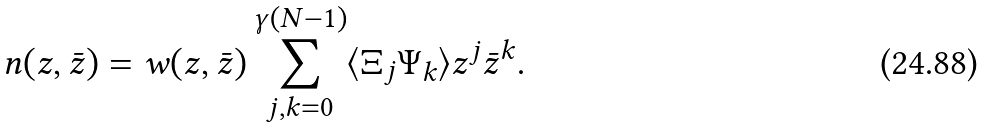Convert formula to latex. <formula><loc_0><loc_0><loc_500><loc_500>n ( z , \bar { z } ) = w ( z , \bar { z } ) \sum _ { j , k = 0 } ^ { \gamma ( N - 1 ) } \langle \Xi _ { j } \Psi _ { k } \rangle z ^ { j } \bar { z } ^ { k } .</formula> 